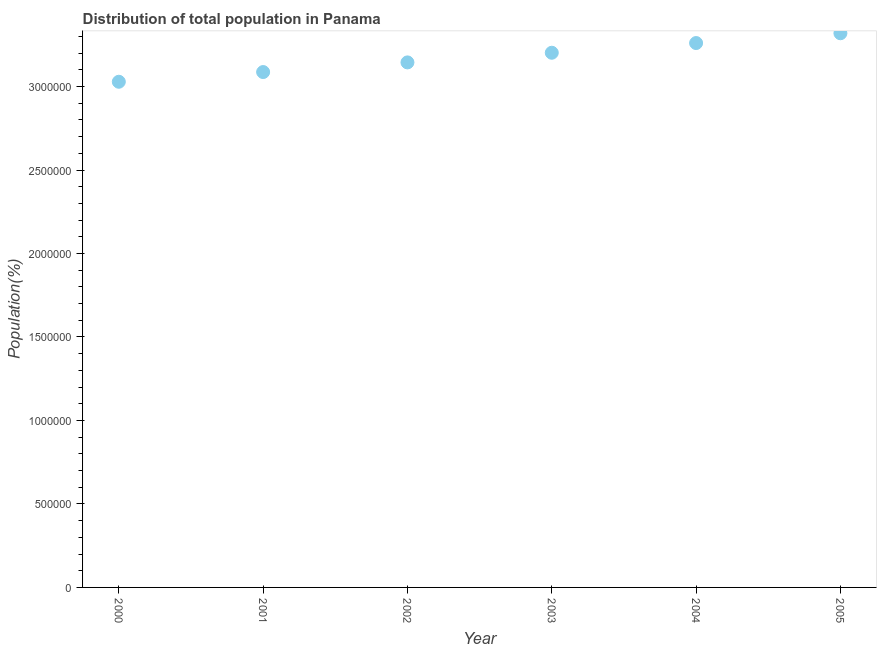What is the population in 2005?
Offer a very short reply. 3.32e+06. Across all years, what is the maximum population?
Provide a succinct answer. 3.32e+06. Across all years, what is the minimum population?
Give a very brief answer. 3.03e+06. In which year was the population maximum?
Your response must be concise. 2005. What is the sum of the population?
Your answer should be very brief. 1.90e+07. What is the difference between the population in 2000 and 2004?
Give a very brief answer. -2.32e+05. What is the average population per year?
Your answer should be very brief. 3.17e+06. What is the median population?
Make the answer very short. 3.17e+06. What is the ratio of the population in 2000 to that in 2001?
Offer a very short reply. 0.98. What is the difference between the highest and the second highest population?
Ensure brevity in your answer.  5.87e+04. What is the difference between the highest and the lowest population?
Give a very brief answer. 2.91e+05. In how many years, is the population greater than the average population taken over all years?
Provide a succinct answer. 3. Does the population monotonically increase over the years?
Ensure brevity in your answer.  Yes. How many years are there in the graph?
Offer a terse response. 6. What is the difference between two consecutive major ticks on the Y-axis?
Provide a short and direct response. 5.00e+05. Are the values on the major ticks of Y-axis written in scientific E-notation?
Offer a terse response. No. Does the graph contain any zero values?
Offer a terse response. No. Does the graph contain grids?
Give a very brief answer. No. What is the title of the graph?
Your response must be concise. Distribution of total population in Panama . What is the label or title of the Y-axis?
Your answer should be compact. Population(%). What is the Population(%) in 2000?
Make the answer very short. 3.03e+06. What is the Population(%) in 2001?
Ensure brevity in your answer.  3.09e+06. What is the Population(%) in 2002?
Provide a short and direct response. 3.14e+06. What is the Population(%) in 2003?
Provide a short and direct response. 3.20e+06. What is the Population(%) in 2004?
Give a very brief answer. 3.26e+06. What is the Population(%) in 2005?
Offer a terse response. 3.32e+06. What is the difference between the Population(%) in 2000 and 2001?
Give a very brief answer. -5.81e+04. What is the difference between the Population(%) in 2000 and 2002?
Your response must be concise. -1.16e+05. What is the difference between the Population(%) in 2000 and 2003?
Your answer should be very brief. -1.74e+05. What is the difference between the Population(%) in 2000 and 2004?
Provide a short and direct response. -2.32e+05. What is the difference between the Population(%) in 2000 and 2005?
Your answer should be very brief. -2.91e+05. What is the difference between the Population(%) in 2001 and 2002?
Offer a very short reply. -5.78e+04. What is the difference between the Population(%) in 2001 and 2003?
Offer a very short reply. -1.16e+05. What is the difference between the Population(%) in 2001 and 2004?
Your answer should be compact. -1.74e+05. What is the difference between the Population(%) in 2001 and 2005?
Make the answer very short. -2.32e+05. What is the difference between the Population(%) in 2002 and 2003?
Your answer should be compact. -5.78e+04. What is the difference between the Population(%) in 2002 and 2004?
Make the answer very short. -1.16e+05. What is the difference between the Population(%) in 2002 and 2005?
Your answer should be compact. -1.75e+05. What is the difference between the Population(%) in 2003 and 2004?
Offer a very short reply. -5.81e+04. What is the difference between the Population(%) in 2003 and 2005?
Give a very brief answer. -1.17e+05. What is the difference between the Population(%) in 2004 and 2005?
Provide a succinct answer. -5.87e+04. What is the ratio of the Population(%) in 2000 to that in 2001?
Provide a short and direct response. 0.98. What is the ratio of the Population(%) in 2000 to that in 2002?
Your response must be concise. 0.96. What is the ratio of the Population(%) in 2000 to that in 2003?
Your answer should be very brief. 0.95. What is the ratio of the Population(%) in 2000 to that in 2004?
Offer a very short reply. 0.93. What is the ratio of the Population(%) in 2000 to that in 2005?
Ensure brevity in your answer.  0.91. What is the ratio of the Population(%) in 2001 to that in 2002?
Offer a terse response. 0.98. What is the ratio of the Population(%) in 2001 to that in 2004?
Make the answer very short. 0.95. What is the ratio of the Population(%) in 2001 to that in 2005?
Your response must be concise. 0.93. What is the ratio of the Population(%) in 2002 to that in 2003?
Your response must be concise. 0.98. What is the ratio of the Population(%) in 2002 to that in 2004?
Ensure brevity in your answer.  0.96. What is the ratio of the Population(%) in 2002 to that in 2005?
Keep it short and to the point. 0.95. What is the ratio of the Population(%) in 2003 to that in 2004?
Provide a short and direct response. 0.98. 